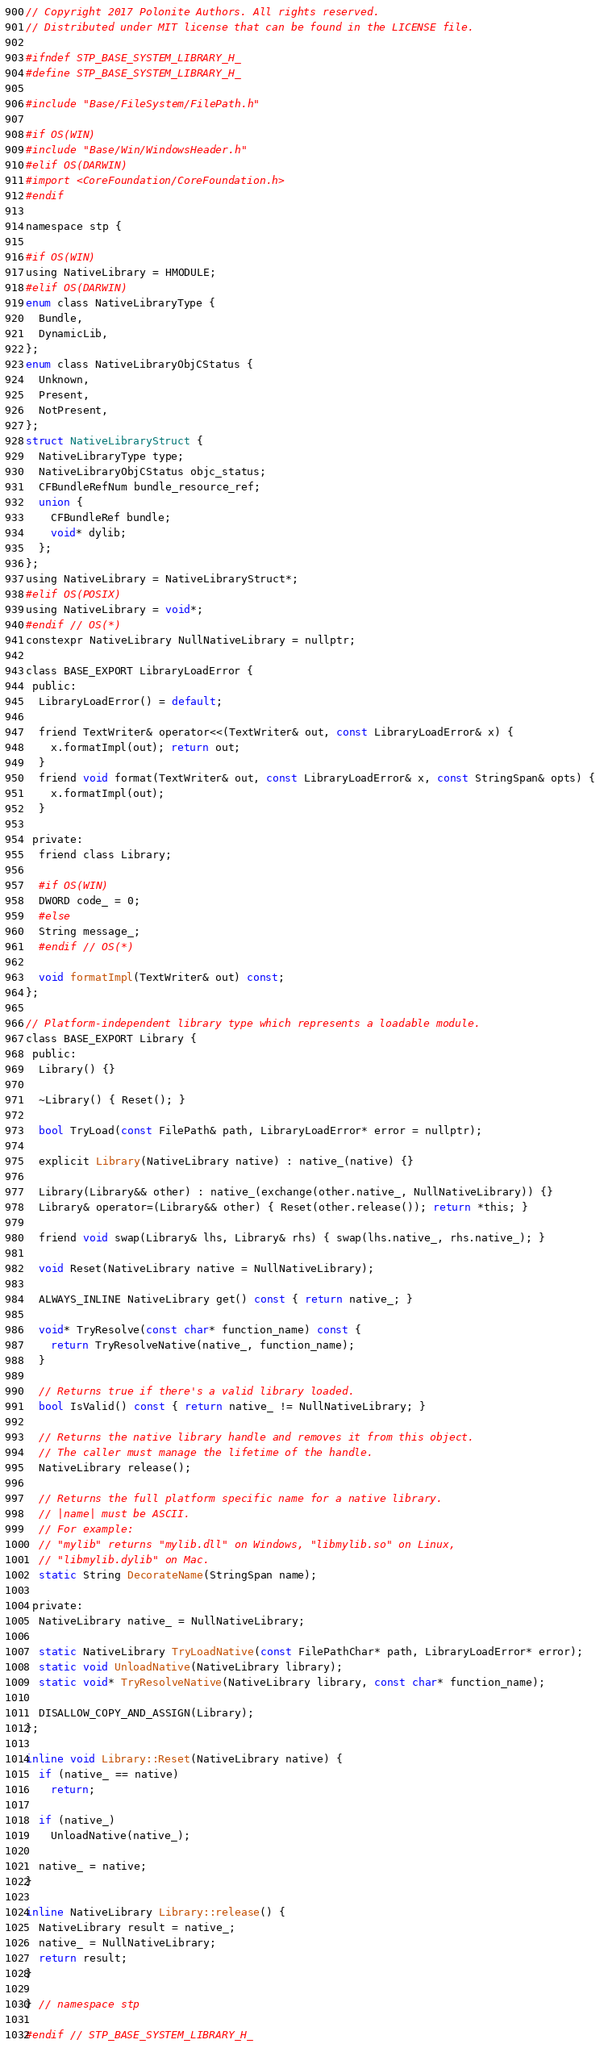<code> <loc_0><loc_0><loc_500><loc_500><_C_>// Copyright 2017 Polonite Authors. All rights reserved.
// Distributed under MIT license that can be found in the LICENSE file.

#ifndef STP_BASE_SYSTEM_LIBRARY_H_
#define STP_BASE_SYSTEM_LIBRARY_H_

#include "Base/FileSystem/FilePath.h"

#if OS(WIN)
#include "Base/Win/WindowsHeader.h"
#elif OS(DARWIN)
#import <CoreFoundation/CoreFoundation.h>
#endif

namespace stp {

#if OS(WIN)
using NativeLibrary = HMODULE;
#elif OS(DARWIN)
enum class NativeLibraryType {
  Bundle,
  DynamicLib,
};
enum class NativeLibraryObjCStatus {
  Unknown,
  Present,
  NotPresent,
};
struct NativeLibraryStruct {
  NativeLibraryType type;
  NativeLibraryObjCStatus objc_status;
  CFBundleRefNum bundle_resource_ref;
  union {
    CFBundleRef bundle;
    void* dylib;
  };
};
using NativeLibrary = NativeLibraryStruct*;
#elif OS(POSIX)
using NativeLibrary = void*;
#endif // OS(*)
constexpr NativeLibrary NullNativeLibrary = nullptr;

class BASE_EXPORT LibraryLoadError {
 public:
  LibraryLoadError() = default;

  friend TextWriter& operator<<(TextWriter& out, const LibraryLoadError& x) {
    x.formatImpl(out); return out;
  }
  friend void format(TextWriter& out, const LibraryLoadError& x, const StringSpan& opts) {
    x.formatImpl(out);
  }

 private:
  friend class Library;

  #if OS(WIN)
  DWORD code_ = 0;
  #else
  String message_;
  #endif // OS(*)

  void formatImpl(TextWriter& out) const;
};

// Platform-independent library type which represents a loadable module.
class BASE_EXPORT Library {
 public:
  Library() {}

  ~Library() { Reset(); }

  bool TryLoad(const FilePath& path, LibraryLoadError* error = nullptr);

  explicit Library(NativeLibrary native) : native_(native) {}

  Library(Library&& other) : native_(exchange(other.native_, NullNativeLibrary)) {}
  Library& operator=(Library&& other) { Reset(other.release()); return *this; }

  friend void swap(Library& lhs, Library& rhs) { swap(lhs.native_, rhs.native_); }

  void Reset(NativeLibrary native = NullNativeLibrary);

  ALWAYS_INLINE NativeLibrary get() const { return native_; }

  void* TryResolve(const char* function_name) const {
    return TryResolveNative(native_, function_name);
  }

  // Returns true if there's a valid library loaded.
  bool IsValid() const { return native_ != NullNativeLibrary; }

  // Returns the native library handle and removes it from this object.
  // The caller must manage the lifetime of the handle.
  NativeLibrary release();

  // Returns the full platform specific name for a native library.
  // |name| must be ASCII.
  // For example:
  // "mylib" returns "mylib.dll" on Windows, "libmylib.so" on Linux,
  // "libmylib.dylib" on Mac.
  static String DecorateName(StringSpan name);

 private:
  NativeLibrary native_ = NullNativeLibrary;

  static NativeLibrary TryLoadNative(const FilePathChar* path, LibraryLoadError* error);
  static void UnloadNative(NativeLibrary library);
  static void* TryResolveNative(NativeLibrary library, const char* function_name);

  DISALLOW_COPY_AND_ASSIGN(Library);
};

inline void Library::Reset(NativeLibrary native) {
  if (native_ == native)
    return;

  if (native_)
    UnloadNative(native_);

  native_ = native;
}

inline NativeLibrary Library::release() {
  NativeLibrary result = native_;
  native_ = NullNativeLibrary;
  return result;
}

} // namespace stp

#endif // STP_BASE_SYSTEM_LIBRARY_H_
</code> 